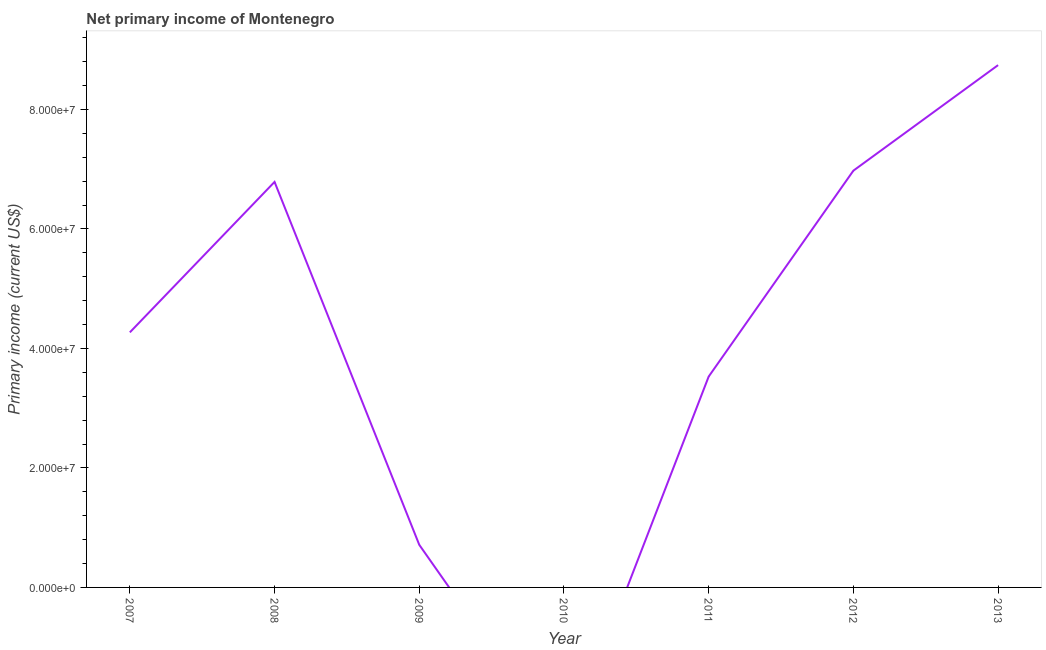What is the amount of primary income in 2010?
Provide a succinct answer. 0. Across all years, what is the maximum amount of primary income?
Provide a succinct answer. 8.74e+07. Across all years, what is the minimum amount of primary income?
Ensure brevity in your answer.  0. In which year was the amount of primary income maximum?
Offer a very short reply. 2013. What is the sum of the amount of primary income?
Give a very brief answer. 3.10e+08. What is the difference between the amount of primary income in 2011 and 2013?
Give a very brief answer. -5.21e+07. What is the average amount of primary income per year?
Give a very brief answer. 4.43e+07. What is the median amount of primary income?
Offer a terse response. 4.27e+07. What is the ratio of the amount of primary income in 2007 to that in 2012?
Your response must be concise. 0.61. What is the difference between the highest and the second highest amount of primary income?
Ensure brevity in your answer.  1.77e+07. What is the difference between the highest and the lowest amount of primary income?
Offer a terse response. 8.74e+07. Does the amount of primary income monotonically increase over the years?
Ensure brevity in your answer.  No. What is the difference between two consecutive major ticks on the Y-axis?
Make the answer very short. 2.00e+07. Are the values on the major ticks of Y-axis written in scientific E-notation?
Ensure brevity in your answer.  Yes. Does the graph contain any zero values?
Your response must be concise. Yes. Does the graph contain grids?
Keep it short and to the point. No. What is the title of the graph?
Offer a terse response. Net primary income of Montenegro. What is the label or title of the Y-axis?
Give a very brief answer. Primary income (current US$). What is the Primary income (current US$) of 2007?
Provide a succinct answer. 4.27e+07. What is the Primary income (current US$) in 2008?
Offer a very short reply. 6.79e+07. What is the Primary income (current US$) of 2009?
Provide a succinct answer. 7.13e+06. What is the Primary income (current US$) of 2010?
Your response must be concise. 0. What is the Primary income (current US$) in 2011?
Provide a succinct answer. 3.53e+07. What is the Primary income (current US$) of 2012?
Provide a succinct answer. 6.98e+07. What is the Primary income (current US$) in 2013?
Give a very brief answer. 8.74e+07. What is the difference between the Primary income (current US$) in 2007 and 2008?
Provide a succinct answer. -2.52e+07. What is the difference between the Primary income (current US$) in 2007 and 2009?
Keep it short and to the point. 3.56e+07. What is the difference between the Primary income (current US$) in 2007 and 2011?
Your response must be concise. 7.40e+06. What is the difference between the Primary income (current US$) in 2007 and 2012?
Your answer should be very brief. -2.71e+07. What is the difference between the Primary income (current US$) in 2007 and 2013?
Your response must be concise. -4.47e+07. What is the difference between the Primary income (current US$) in 2008 and 2009?
Your answer should be very brief. 6.07e+07. What is the difference between the Primary income (current US$) in 2008 and 2011?
Make the answer very short. 3.26e+07. What is the difference between the Primary income (current US$) in 2008 and 2012?
Your response must be concise. -1.88e+06. What is the difference between the Primary income (current US$) in 2008 and 2013?
Give a very brief answer. -1.96e+07. What is the difference between the Primary income (current US$) in 2009 and 2011?
Offer a terse response. -2.82e+07. What is the difference between the Primary income (current US$) in 2009 and 2012?
Provide a short and direct response. -6.26e+07. What is the difference between the Primary income (current US$) in 2009 and 2013?
Offer a terse response. -8.03e+07. What is the difference between the Primary income (current US$) in 2011 and 2012?
Keep it short and to the point. -3.45e+07. What is the difference between the Primary income (current US$) in 2011 and 2013?
Provide a succinct answer. -5.21e+07. What is the difference between the Primary income (current US$) in 2012 and 2013?
Offer a terse response. -1.77e+07. What is the ratio of the Primary income (current US$) in 2007 to that in 2008?
Your response must be concise. 0.63. What is the ratio of the Primary income (current US$) in 2007 to that in 2009?
Provide a succinct answer. 5.99. What is the ratio of the Primary income (current US$) in 2007 to that in 2011?
Make the answer very short. 1.21. What is the ratio of the Primary income (current US$) in 2007 to that in 2012?
Offer a very short reply. 0.61. What is the ratio of the Primary income (current US$) in 2007 to that in 2013?
Your response must be concise. 0.49. What is the ratio of the Primary income (current US$) in 2008 to that in 2009?
Offer a terse response. 9.52. What is the ratio of the Primary income (current US$) in 2008 to that in 2011?
Offer a terse response. 1.92. What is the ratio of the Primary income (current US$) in 2008 to that in 2013?
Your response must be concise. 0.78. What is the ratio of the Primary income (current US$) in 2009 to that in 2011?
Your response must be concise. 0.2. What is the ratio of the Primary income (current US$) in 2009 to that in 2012?
Your answer should be compact. 0.1. What is the ratio of the Primary income (current US$) in 2009 to that in 2013?
Offer a terse response. 0.08. What is the ratio of the Primary income (current US$) in 2011 to that in 2012?
Make the answer very short. 0.51. What is the ratio of the Primary income (current US$) in 2011 to that in 2013?
Your answer should be very brief. 0.4. What is the ratio of the Primary income (current US$) in 2012 to that in 2013?
Offer a very short reply. 0.8. 